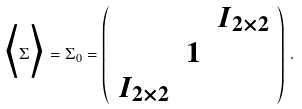<formula> <loc_0><loc_0><loc_500><loc_500>\Big < \Sigma \Big > = \Sigma _ { 0 } = \left ( \begin{array} { c c c } & & I _ { 2 \times 2 } \\ & 1 & \\ I _ { 2 \times 2 } & & \end{array} \right ) \, .</formula> 